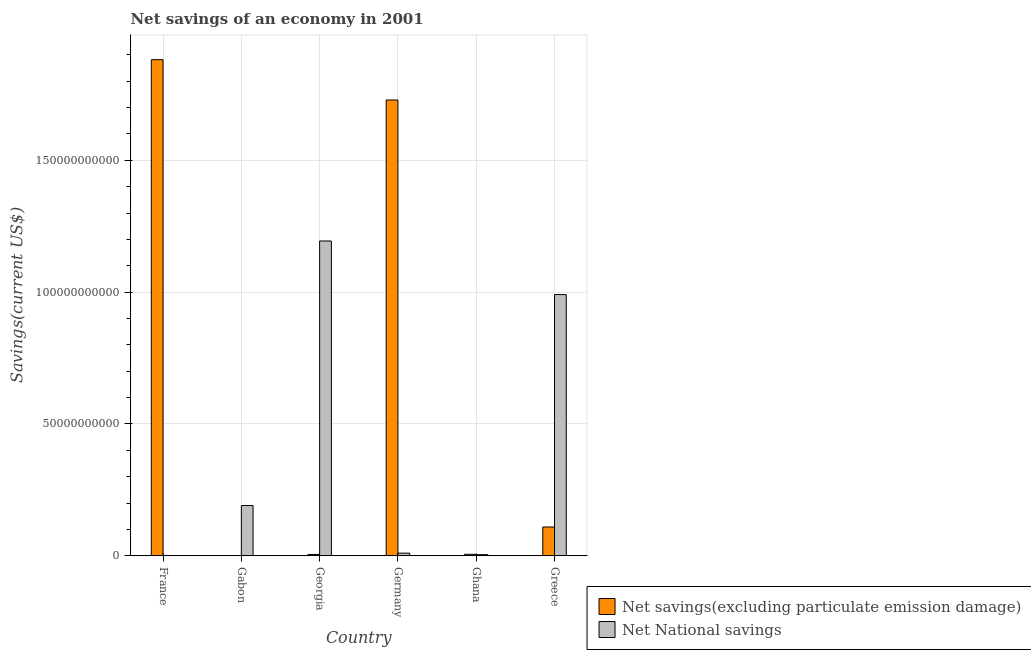Are the number of bars per tick equal to the number of legend labels?
Offer a terse response. No. What is the label of the 2nd group of bars from the left?
Give a very brief answer. Gabon. What is the net national savings in Georgia?
Give a very brief answer. 1.19e+11. Across all countries, what is the maximum net savings(excluding particulate emission damage)?
Your answer should be compact. 1.88e+11. Across all countries, what is the minimum net national savings?
Provide a short and direct response. 3.93e+07. What is the total net national savings in the graph?
Your response must be concise. 2.39e+11. What is the difference between the net national savings in Germany and that in Ghana?
Your response must be concise. 5.68e+08. What is the difference between the net savings(excluding particulate emission damage) in Ghana and the net national savings in Germany?
Your response must be concise. -4.36e+08. What is the average net national savings per country?
Your answer should be very brief. 3.98e+1. What is the difference between the net savings(excluding particulate emission damage) and net national savings in Ghana?
Give a very brief answer. 1.33e+08. What is the ratio of the net national savings in Gabon to that in Germany?
Your answer should be very brief. 19.05. Is the net national savings in Germany less than that in Ghana?
Your answer should be very brief. No. What is the difference between the highest and the second highest net savings(excluding particulate emission damage)?
Your answer should be compact. 1.53e+1. What is the difference between the highest and the lowest net national savings?
Ensure brevity in your answer.  1.19e+11. In how many countries, is the net savings(excluding particulate emission damage) greater than the average net savings(excluding particulate emission damage) taken over all countries?
Offer a terse response. 2. How many bars are there?
Provide a short and direct response. 11. Are all the bars in the graph horizontal?
Your answer should be very brief. No. How many countries are there in the graph?
Your answer should be compact. 6. Does the graph contain any zero values?
Provide a short and direct response. Yes. Does the graph contain grids?
Ensure brevity in your answer.  Yes. What is the title of the graph?
Keep it short and to the point. Net savings of an economy in 2001. Does "Secondary Education" appear as one of the legend labels in the graph?
Your answer should be compact. No. What is the label or title of the Y-axis?
Provide a succinct answer. Savings(current US$). What is the Savings(current US$) in Net savings(excluding particulate emission damage) in France?
Provide a short and direct response. 1.88e+11. What is the Savings(current US$) in Net National savings in France?
Keep it short and to the point. 3.93e+07. What is the Savings(current US$) of Net savings(excluding particulate emission damage) in Gabon?
Offer a very short reply. 0. What is the Savings(current US$) of Net National savings in Gabon?
Give a very brief answer. 1.91e+1. What is the Savings(current US$) in Net savings(excluding particulate emission damage) in Georgia?
Ensure brevity in your answer.  5.11e+08. What is the Savings(current US$) in Net National savings in Georgia?
Keep it short and to the point. 1.19e+11. What is the Savings(current US$) in Net savings(excluding particulate emission damage) in Germany?
Your answer should be compact. 1.73e+11. What is the Savings(current US$) of Net National savings in Germany?
Ensure brevity in your answer.  1.00e+09. What is the Savings(current US$) in Net savings(excluding particulate emission damage) in Ghana?
Your response must be concise. 5.65e+08. What is the Savings(current US$) in Net National savings in Ghana?
Offer a terse response. 4.33e+08. What is the Savings(current US$) in Net savings(excluding particulate emission damage) in Greece?
Provide a short and direct response. 1.09e+1. What is the Savings(current US$) in Net National savings in Greece?
Your answer should be compact. 9.91e+1. Across all countries, what is the maximum Savings(current US$) in Net savings(excluding particulate emission damage)?
Offer a terse response. 1.88e+11. Across all countries, what is the maximum Savings(current US$) in Net National savings?
Keep it short and to the point. 1.19e+11. Across all countries, what is the minimum Savings(current US$) in Net savings(excluding particulate emission damage)?
Provide a succinct answer. 0. Across all countries, what is the minimum Savings(current US$) of Net National savings?
Your response must be concise. 3.93e+07. What is the total Savings(current US$) in Net savings(excluding particulate emission damage) in the graph?
Ensure brevity in your answer.  3.73e+11. What is the total Savings(current US$) in Net National savings in the graph?
Offer a terse response. 2.39e+11. What is the difference between the Savings(current US$) in Net National savings in France and that in Gabon?
Provide a succinct answer. -1.90e+1. What is the difference between the Savings(current US$) in Net savings(excluding particulate emission damage) in France and that in Georgia?
Your answer should be very brief. 1.88e+11. What is the difference between the Savings(current US$) in Net National savings in France and that in Georgia?
Offer a very short reply. -1.19e+11. What is the difference between the Savings(current US$) in Net savings(excluding particulate emission damage) in France and that in Germany?
Provide a succinct answer. 1.53e+1. What is the difference between the Savings(current US$) of Net National savings in France and that in Germany?
Ensure brevity in your answer.  -9.61e+08. What is the difference between the Savings(current US$) of Net savings(excluding particulate emission damage) in France and that in Ghana?
Your answer should be compact. 1.88e+11. What is the difference between the Savings(current US$) in Net National savings in France and that in Ghana?
Give a very brief answer. -3.93e+08. What is the difference between the Savings(current US$) of Net savings(excluding particulate emission damage) in France and that in Greece?
Your answer should be compact. 1.77e+11. What is the difference between the Savings(current US$) in Net National savings in France and that in Greece?
Ensure brevity in your answer.  -9.90e+1. What is the difference between the Savings(current US$) in Net National savings in Gabon and that in Georgia?
Your answer should be compact. -1.00e+11. What is the difference between the Savings(current US$) of Net National savings in Gabon and that in Germany?
Your answer should be compact. 1.81e+1. What is the difference between the Savings(current US$) in Net National savings in Gabon and that in Ghana?
Provide a short and direct response. 1.86e+1. What is the difference between the Savings(current US$) of Net National savings in Gabon and that in Greece?
Make the answer very short. -8.00e+1. What is the difference between the Savings(current US$) in Net savings(excluding particulate emission damage) in Georgia and that in Germany?
Keep it short and to the point. -1.72e+11. What is the difference between the Savings(current US$) in Net National savings in Georgia and that in Germany?
Make the answer very short. 1.18e+11. What is the difference between the Savings(current US$) of Net savings(excluding particulate emission damage) in Georgia and that in Ghana?
Your response must be concise. -5.38e+07. What is the difference between the Savings(current US$) in Net National savings in Georgia and that in Ghana?
Your answer should be very brief. 1.19e+11. What is the difference between the Savings(current US$) in Net savings(excluding particulate emission damage) in Georgia and that in Greece?
Your response must be concise. -1.04e+1. What is the difference between the Savings(current US$) of Net National savings in Georgia and that in Greece?
Offer a terse response. 2.03e+1. What is the difference between the Savings(current US$) of Net savings(excluding particulate emission damage) in Germany and that in Ghana?
Your answer should be very brief. 1.72e+11. What is the difference between the Savings(current US$) of Net National savings in Germany and that in Ghana?
Make the answer very short. 5.68e+08. What is the difference between the Savings(current US$) in Net savings(excluding particulate emission damage) in Germany and that in Greece?
Ensure brevity in your answer.  1.62e+11. What is the difference between the Savings(current US$) of Net National savings in Germany and that in Greece?
Make the answer very short. -9.81e+1. What is the difference between the Savings(current US$) of Net savings(excluding particulate emission damage) in Ghana and that in Greece?
Your answer should be very brief. -1.04e+1. What is the difference between the Savings(current US$) of Net National savings in Ghana and that in Greece?
Provide a short and direct response. -9.86e+1. What is the difference between the Savings(current US$) in Net savings(excluding particulate emission damage) in France and the Savings(current US$) in Net National savings in Gabon?
Provide a short and direct response. 1.69e+11. What is the difference between the Savings(current US$) of Net savings(excluding particulate emission damage) in France and the Savings(current US$) of Net National savings in Georgia?
Keep it short and to the point. 6.88e+1. What is the difference between the Savings(current US$) in Net savings(excluding particulate emission damage) in France and the Savings(current US$) in Net National savings in Germany?
Ensure brevity in your answer.  1.87e+11. What is the difference between the Savings(current US$) of Net savings(excluding particulate emission damage) in France and the Savings(current US$) of Net National savings in Ghana?
Provide a succinct answer. 1.88e+11. What is the difference between the Savings(current US$) in Net savings(excluding particulate emission damage) in France and the Savings(current US$) in Net National savings in Greece?
Give a very brief answer. 8.91e+1. What is the difference between the Savings(current US$) of Net savings(excluding particulate emission damage) in Georgia and the Savings(current US$) of Net National savings in Germany?
Offer a very short reply. -4.89e+08. What is the difference between the Savings(current US$) of Net savings(excluding particulate emission damage) in Georgia and the Savings(current US$) of Net National savings in Ghana?
Give a very brief answer. 7.88e+07. What is the difference between the Savings(current US$) of Net savings(excluding particulate emission damage) in Georgia and the Savings(current US$) of Net National savings in Greece?
Offer a very short reply. -9.86e+1. What is the difference between the Savings(current US$) of Net savings(excluding particulate emission damage) in Germany and the Savings(current US$) of Net National savings in Ghana?
Your answer should be compact. 1.72e+11. What is the difference between the Savings(current US$) in Net savings(excluding particulate emission damage) in Germany and the Savings(current US$) in Net National savings in Greece?
Provide a short and direct response. 7.38e+1. What is the difference between the Savings(current US$) in Net savings(excluding particulate emission damage) in Ghana and the Savings(current US$) in Net National savings in Greece?
Keep it short and to the point. -9.85e+1. What is the average Savings(current US$) in Net savings(excluding particulate emission damage) per country?
Give a very brief answer. 6.22e+1. What is the average Savings(current US$) in Net National savings per country?
Offer a terse response. 3.98e+1. What is the difference between the Savings(current US$) in Net savings(excluding particulate emission damage) and Savings(current US$) in Net National savings in France?
Provide a succinct answer. 1.88e+11. What is the difference between the Savings(current US$) of Net savings(excluding particulate emission damage) and Savings(current US$) of Net National savings in Georgia?
Make the answer very short. -1.19e+11. What is the difference between the Savings(current US$) in Net savings(excluding particulate emission damage) and Savings(current US$) in Net National savings in Germany?
Your response must be concise. 1.72e+11. What is the difference between the Savings(current US$) of Net savings(excluding particulate emission damage) and Savings(current US$) of Net National savings in Ghana?
Make the answer very short. 1.33e+08. What is the difference between the Savings(current US$) of Net savings(excluding particulate emission damage) and Savings(current US$) of Net National savings in Greece?
Ensure brevity in your answer.  -8.82e+1. What is the ratio of the Savings(current US$) of Net National savings in France to that in Gabon?
Provide a succinct answer. 0. What is the ratio of the Savings(current US$) in Net savings(excluding particulate emission damage) in France to that in Georgia?
Keep it short and to the point. 368.01. What is the ratio of the Savings(current US$) of Net savings(excluding particulate emission damage) in France to that in Germany?
Your answer should be compact. 1.09. What is the ratio of the Savings(current US$) of Net National savings in France to that in Germany?
Ensure brevity in your answer.  0.04. What is the ratio of the Savings(current US$) in Net savings(excluding particulate emission damage) in France to that in Ghana?
Ensure brevity in your answer.  333. What is the ratio of the Savings(current US$) of Net National savings in France to that in Ghana?
Offer a very short reply. 0.09. What is the ratio of the Savings(current US$) of Net savings(excluding particulate emission damage) in France to that in Greece?
Your answer should be compact. 17.23. What is the ratio of the Savings(current US$) in Net National savings in France to that in Greece?
Ensure brevity in your answer.  0. What is the ratio of the Savings(current US$) of Net National savings in Gabon to that in Georgia?
Give a very brief answer. 0.16. What is the ratio of the Savings(current US$) of Net National savings in Gabon to that in Germany?
Provide a short and direct response. 19.05. What is the ratio of the Savings(current US$) of Net National savings in Gabon to that in Ghana?
Your answer should be very brief. 44.07. What is the ratio of the Savings(current US$) in Net National savings in Gabon to that in Greece?
Your answer should be compact. 0.19. What is the ratio of the Savings(current US$) of Net savings(excluding particulate emission damage) in Georgia to that in Germany?
Make the answer very short. 0. What is the ratio of the Savings(current US$) in Net National savings in Georgia to that in Germany?
Provide a short and direct response. 119.33. What is the ratio of the Savings(current US$) of Net savings(excluding particulate emission damage) in Georgia to that in Ghana?
Your answer should be compact. 0.9. What is the ratio of the Savings(current US$) in Net National savings in Georgia to that in Ghana?
Offer a terse response. 276.05. What is the ratio of the Savings(current US$) in Net savings(excluding particulate emission damage) in Georgia to that in Greece?
Give a very brief answer. 0.05. What is the ratio of the Savings(current US$) of Net National savings in Georgia to that in Greece?
Your response must be concise. 1.21. What is the ratio of the Savings(current US$) of Net savings(excluding particulate emission damage) in Germany to that in Ghana?
Your response must be concise. 305.95. What is the ratio of the Savings(current US$) in Net National savings in Germany to that in Ghana?
Provide a succinct answer. 2.31. What is the ratio of the Savings(current US$) in Net savings(excluding particulate emission damage) in Germany to that in Greece?
Your answer should be very brief. 15.83. What is the ratio of the Savings(current US$) in Net National savings in Germany to that in Greece?
Your response must be concise. 0.01. What is the ratio of the Savings(current US$) of Net savings(excluding particulate emission damage) in Ghana to that in Greece?
Offer a very short reply. 0.05. What is the ratio of the Savings(current US$) in Net National savings in Ghana to that in Greece?
Your response must be concise. 0. What is the difference between the highest and the second highest Savings(current US$) of Net savings(excluding particulate emission damage)?
Provide a short and direct response. 1.53e+1. What is the difference between the highest and the second highest Savings(current US$) of Net National savings?
Provide a succinct answer. 2.03e+1. What is the difference between the highest and the lowest Savings(current US$) in Net savings(excluding particulate emission damage)?
Provide a short and direct response. 1.88e+11. What is the difference between the highest and the lowest Savings(current US$) of Net National savings?
Offer a very short reply. 1.19e+11. 